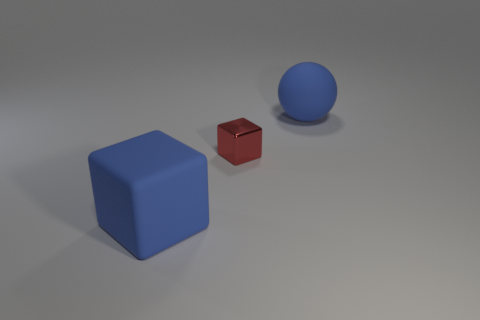Are there any matte blocks that have the same size as the red metallic thing?
Provide a short and direct response. No. How many objects are big blue rubber objects to the right of the blue matte cube or things behind the tiny shiny cube?
Offer a terse response. 1. There is a rubber object to the left of the large blue matte ball; is its size the same as the rubber ball behind the red metal thing?
Provide a short and direct response. Yes. There is a big blue object that is on the left side of the large rubber sphere; is there a big object on the left side of it?
Make the answer very short. No. There is a big cube; what number of large blue rubber blocks are to the left of it?
Provide a succinct answer. 0. What number of other objects are there of the same color as the matte ball?
Your response must be concise. 1. Are there fewer balls in front of the blue matte ball than objects that are left of the blue rubber cube?
Your response must be concise. No. How many objects are large blue matte objects left of the ball or small yellow rubber balls?
Your answer should be very brief. 1. There is a metallic block; is it the same size as the matte object right of the matte block?
Provide a short and direct response. No. There is a rubber object that is the same shape as the red metal object; what size is it?
Ensure brevity in your answer.  Large. 